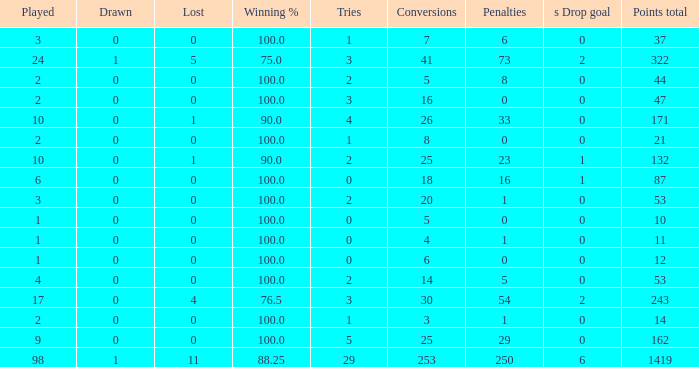What is the least number of penalties he got when his point total was over 1419 in more than 98 games? None. 